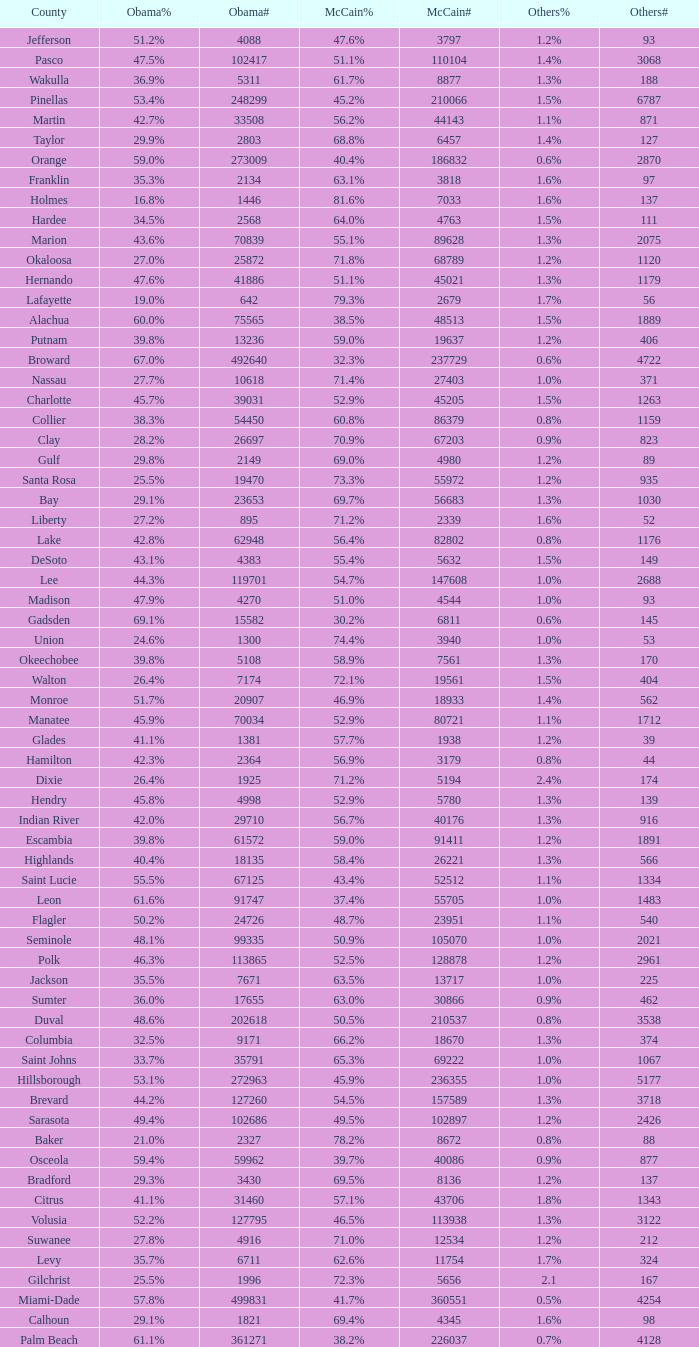What percentage was the others vote when McCain had 52.9% and less than 45205.0 voters? 1.3%. 